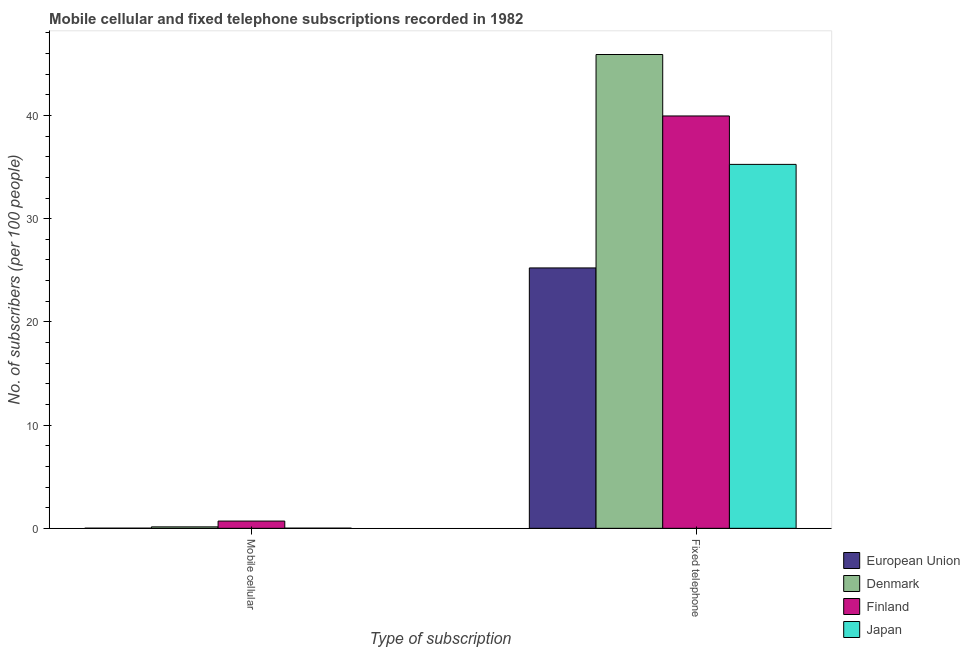How many different coloured bars are there?
Provide a succinct answer. 4. How many groups of bars are there?
Make the answer very short. 2. Are the number of bars on each tick of the X-axis equal?
Your answer should be compact. Yes. What is the label of the 1st group of bars from the left?
Keep it short and to the point. Mobile cellular. What is the number of fixed telephone subscribers in European Union?
Your answer should be compact. 25.23. Across all countries, what is the maximum number of fixed telephone subscribers?
Keep it short and to the point. 45.9. Across all countries, what is the minimum number of mobile cellular subscribers?
Offer a terse response. 0.01. In which country was the number of mobile cellular subscribers minimum?
Provide a short and direct response. European Union. What is the total number of mobile cellular subscribers in the graph?
Provide a succinct answer. 0.87. What is the difference between the number of mobile cellular subscribers in Denmark and that in Finland?
Your answer should be compact. -0.56. What is the difference between the number of fixed telephone subscribers in Finland and the number of mobile cellular subscribers in European Union?
Offer a terse response. 39.93. What is the average number of fixed telephone subscribers per country?
Offer a terse response. 36.58. What is the difference between the number of fixed telephone subscribers and number of mobile cellular subscribers in Finland?
Give a very brief answer. 39.25. What is the ratio of the number of fixed telephone subscribers in Japan to that in Finland?
Your answer should be very brief. 0.88. In how many countries, is the number of mobile cellular subscribers greater than the average number of mobile cellular subscribers taken over all countries?
Offer a very short reply. 1. What does the 3rd bar from the left in Mobile cellular represents?
Your response must be concise. Finland. What does the 4th bar from the right in Fixed telephone represents?
Make the answer very short. European Union. How many bars are there?
Your response must be concise. 8. Are the values on the major ticks of Y-axis written in scientific E-notation?
Your answer should be very brief. No. Does the graph contain grids?
Offer a very short reply. No. How many legend labels are there?
Offer a terse response. 4. What is the title of the graph?
Give a very brief answer. Mobile cellular and fixed telephone subscriptions recorded in 1982. What is the label or title of the X-axis?
Provide a short and direct response. Type of subscription. What is the label or title of the Y-axis?
Keep it short and to the point. No. of subscribers (per 100 people). What is the No. of subscribers (per 100 people) in European Union in Mobile cellular?
Make the answer very short. 0.01. What is the No. of subscribers (per 100 people) in Denmark in Mobile cellular?
Your answer should be compact. 0.14. What is the No. of subscribers (per 100 people) in Finland in Mobile cellular?
Your answer should be compact. 0.7. What is the No. of subscribers (per 100 people) of Japan in Mobile cellular?
Your response must be concise. 0.02. What is the No. of subscribers (per 100 people) of European Union in Fixed telephone?
Offer a terse response. 25.23. What is the No. of subscribers (per 100 people) in Denmark in Fixed telephone?
Give a very brief answer. 45.9. What is the No. of subscribers (per 100 people) in Finland in Fixed telephone?
Give a very brief answer. 39.95. What is the No. of subscribers (per 100 people) of Japan in Fixed telephone?
Provide a succinct answer. 35.26. Across all Type of subscription, what is the maximum No. of subscribers (per 100 people) of European Union?
Keep it short and to the point. 25.23. Across all Type of subscription, what is the maximum No. of subscribers (per 100 people) in Denmark?
Offer a terse response. 45.9. Across all Type of subscription, what is the maximum No. of subscribers (per 100 people) of Finland?
Provide a short and direct response. 39.95. Across all Type of subscription, what is the maximum No. of subscribers (per 100 people) of Japan?
Offer a very short reply. 35.26. Across all Type of subscription, what is the minimum No. of subscribers (per 100 people) in European Union?
Offer a terse response. 0.01. Across all Type of subscription, what is the minimum No. of subscribers (per 100 people) of Denmark?
Provide a succinct answer. 0.14. Across all Type of subscription, what is the minimum No. of subscribers (per 100 people) of Finland?
Offer a very short reply. 0.7. Across all Type of subscription, what is the minimum No. of subscribers (per 100 people) in Japan?
Provide a succinct answer. 0.02. What is the total No. of subscribers (per 100 people) in European Union in the graph?
Make the answer very short. 25.24. What is the total No. of subscribers (per 100 people) in Denmark in the graph?
Your answer should be very brief. 46.04. What is the total No. of subscribers (per 100 people) of Finland in the graph?
Provide a short and direct response. 40.65. What is the total No. of subscribers (per 100 people) in Japan in the graph?
Your response must be concise. 35.27. What is the difference between the No. of subscribers (per 100 people) of European Union in Mobile cellular and that in Fixed telephone?
Your answer should be compact. -25.21. What is the difference between the No. of subscribers (per 100 people) in Denmark in Mobile cellular and that in Fixed telephone?
Your answer should be very brief. -45.76. What is the difference between the No. of subscribers (per 100 people) in Finland in Mobile cellular and that in Fixed telephone?
Your answer should be very brief. -39.25. What is the difference between the No. of subscribers (per 100 people) of Japan in Mobile cellular and that in Fixed telephone?
Offer a very short reply. -35.24. What is the difference between the No. of subscribers (per 100 people) of European Union in Mobile cellular and the No. of subscribers (per 100 people) of Denmark in Fixed telephone?
Make the answer very short. -45.89. What is the difference between the No. of subscribers (per 100 people) in European Union in Mobile cellular and the No. of subscribers (per 100 people) in Finland in Fixed telephone?
Offer a terse response. -39.93. What is the difference between the No. of subscribers (per 100 people) of European Union in Mobile cellular and the No. of subscribers (per 100 people) of Japan in Fixed telephone?
Keep it short and to the point. -35.24. What is the difference between the No. of subscribers (per 100 people) in Denmark in Mobile cellular and the No. of subscribers (per 100 people) in Finland in Fixed telephone?
Your answer should be compact. -39.81. What is the difference between the No. of subscribers (per 100 people) of Denmark in Mobile cellular and the No. of subscribers (per 100 people) of Japan in Fixed telephone?
Give a very brief answer. -35.12. What is the difference between the No. of subscribers (per 100 people) in Finland in Mobile cellular and the No. of subscribers (per 100 people) in Japan in Fixed telephone?
Your response must be concise. -34.56. What is the average No. of subscribers (per 100 people) in European Union per Type of subscription?
Provide a succinct answer. 12.62. What is the average No. of subscribers (per 100 people) in Denmark per Type of subscription?
Make the answer very short. 23.02. What is the average No. of subscribers (per 100 people) in Finland per Type of subscription?
Keep it short and to the point. 20.33. What is the average No. of subscribers (per 100 people) in Japan per Type of subscription?
Your answer should be very brief. 17.64. What is the difference between the No. of subscribers (per 100 people) of European Union and No. of subscribers (per 100 people) of Denmark in Mobile cellular?
Make the answer very short. -0.13. What is the difference between the No. of subscribers (per 100 people) in European Union and No. of subscribers (per 100 people) in Finland in Mobile cellular?
Provide a short and direct response. -0.69. What is the difference between the No. of subscribers (per 100 people) of European Union and No. of subscribers (per 100 people) of Japan in Mobile cellular?
Provide a succinct answer. -0. What is the difference between the No. of subscribers (per 100 people) of Denmark and No. of subscribers (per 100 people) of Finland in Mobile cellular?
Make the answer very short. -0.56. What is the difference between the No. of subscribers (per 100 people) in Denmark and No. of subscribers (per 100 people) in Japan in Mobile cellular?
Give a very brief answer. 0.12. What is the difference between the No. of subscribers (per 100 people) of Finland and No. of subscribers (per 100 people) of Japan in Mobile cellular?
Provide a short and direct response. 0.69. What is the difference between the No. of subscribers (per 100 people) in European Union and No. of subscribers (per 100 people) in Denmark in Fixed telephone?
Ensure brevity in your answer.  -20.68. What is the difference between the No. of subscribers (per 100 people) of European Union and No. of subscribers (per 100 people) of Finland in Fixed telephone?
Provide a succinct answer. -14.72. What is the difference between the No. of subscribers (per 100 people) of European Union and No. of subscribers (per 100 people) of Japan in Fixed telephone?
Your answer should be compact. -10.03. What is the difference between the No. of subscribers (per 100 people) of Denmark and No. of subscribers (per 100 people) of Finland in Fixed telephone?
Make the answer very short. 5.95. What is the difference between the No. of subscribers (per 100 people) of Denmark and No. of subscribers (per 100 people) of Japan in Fixed telephone?
Ensure brevity in your answer.  10.64. What is the difference between the No. of subscribers (per 100 people) of Finland and No. of subscribers (per 100 people) of Japan in Fixed telephone?
Offer a very short reply. 4.69. What is the ratio of the No. of subscribers (per 100 people) of European Union in Mobile cellular to that in Fixed telephone?
Offer a terse response. 0. What is the ratio of the No. of subscribers (per 100 people) in Denmark in Mobile cellular to that in Fixed telephone?
Keep it short and to the point. 0. What is the ratio of the No. of subscribers (per 100 people) in Finland in Mobile cellular to that in Fixed telephone?
Your response must be concise. 0.02. What is the ratio of the No. of subscribers (per 100 people) in Japan in Mobile cellular to that in Fixed telephone?
Your answer should be compact. 0. What is the difference between the highest and the second highest No. of subscribers (per 100 people) of European Union?
Give a very brief answer. 25.21. What is the difference between the highest and the second highest No. of subscribers (per 100 people) of Denmark?
Give a very brief answer. 45.76. What is the difference between the highest and the second highest No. of subscribers (per 100 people) of Finland?
Your answer should be compact. 39.25. What is the difference between the highest and the second highest No. of subscribers (per 100 people) of Japan?
Keep it short and to the point. 35.24. What is the difference between the highest and the lowest No. of subscribers (per 100 people) of European Union?
Ensure brevity in your answer.  25.21. What is the difference between the highest and the lowest No. of subscribers (per 100 people) in Denmark?
Provide a short and direct response. 45.76. What is the difference between the highest and the lowest No. of subscribers (per 100 people) of Finland?
Your answer should be compact. 39.25. What is the difference between the highest and the lowest No. of subscribers (per 100 people) of Japan?
Provide a short and direct response. 35.24. 